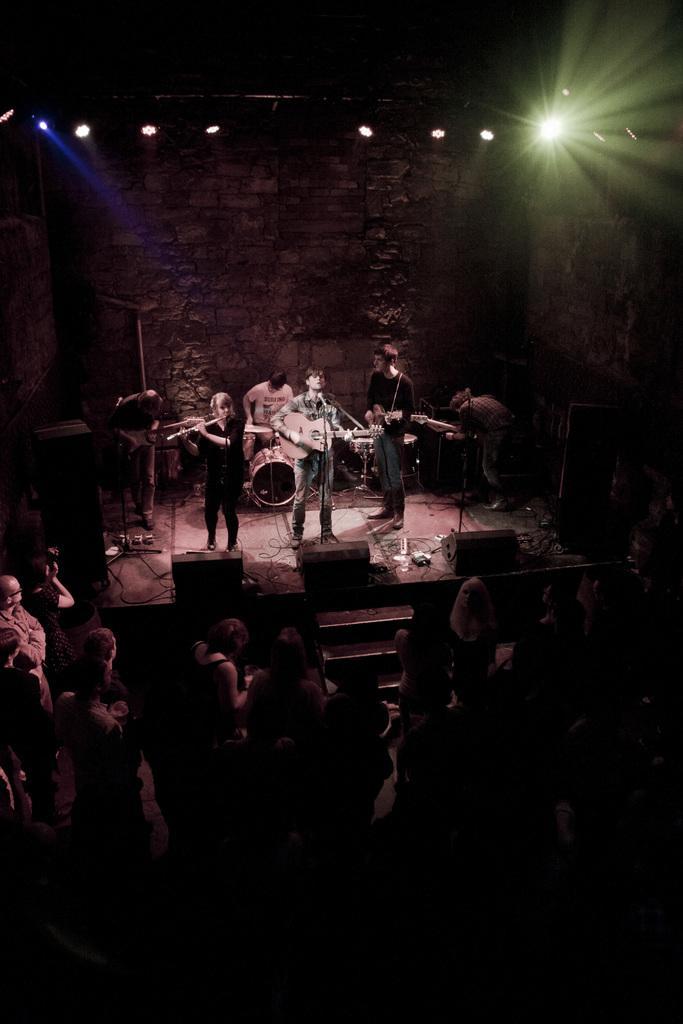Could you give a brief overview of what you see in this image? In this image we can see few persons are playing musical instruments on the stage, one of them is playing flute, another one is playing jazz, three persons are playing guitars, one person is singing, there are few mics, speakers, lights, in front of the stage there are few people listening to the music, we can also see a wall. 